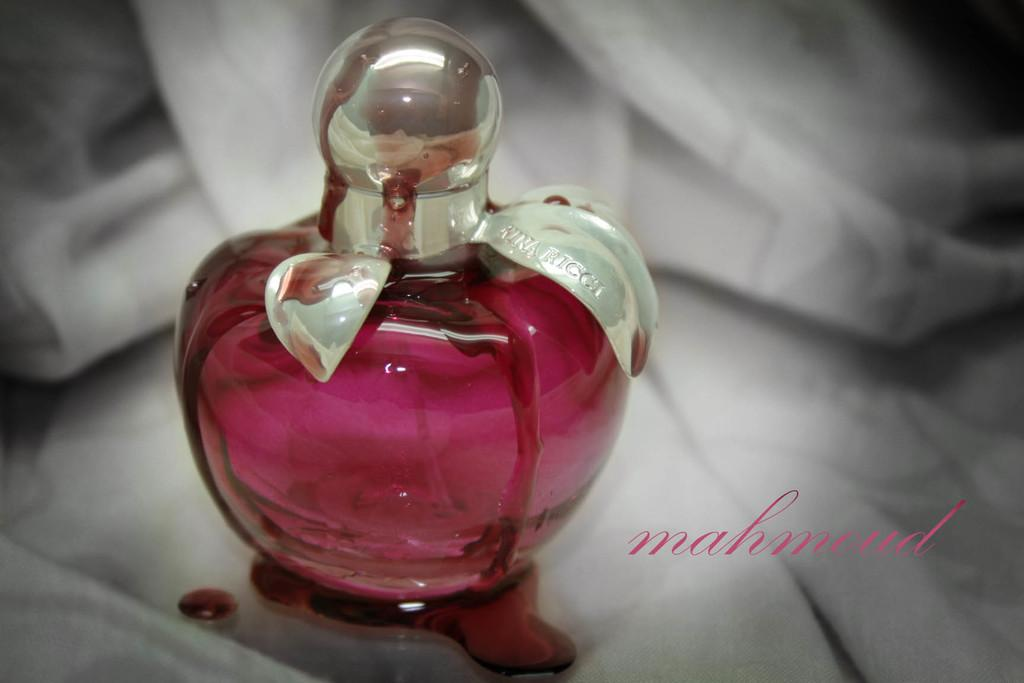<image>
Offer a succinct explanation of the picture presented. a pink bottle of perfume with a white ribbon reading Nina Ricci on a white scarf 